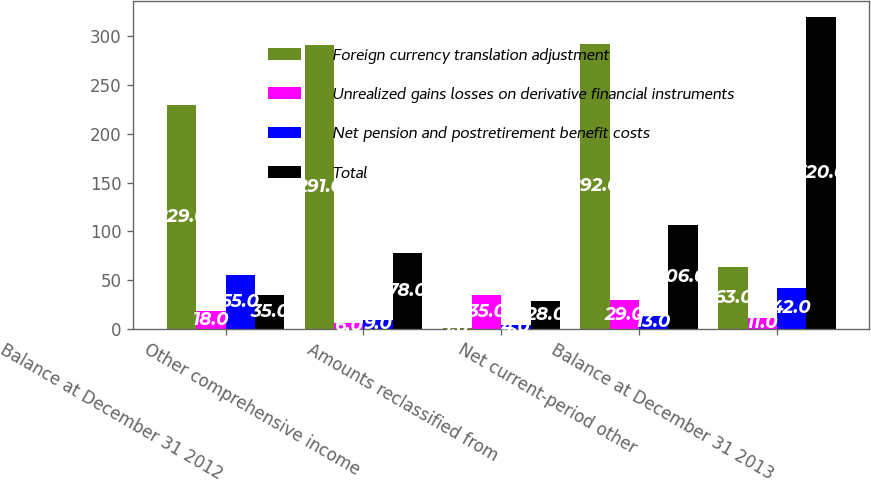<chart> <loc_0><loc_0><loc_500><loc_500><stacked_bar_chart><ecel><fcel>Balance at December 31 2012<fcel>Other comprehensive income<fcel>Amounts reclassified from<fcel>Net current-period other<fcel>Balance at December 31 2013<nl><fcel>Foreign currency translation adjustment<fcel>229<fcel>291<fcel>1<fcel>292<fcel>63<nl><fcel>Unrealized gains losses on derivative financial instruments<fcel>18<fcel>6<fcel>35<fcel>29<fcel>11<nl><fcel>Net pension and postretirement benefit costs<fcel>55<fcel>9<fcel>4<fcel>13<fcel>42<nl><fcel>Total<fcel>35<fcel>78<fcel>28<fcel>106<fcel>320<nl></chart> 